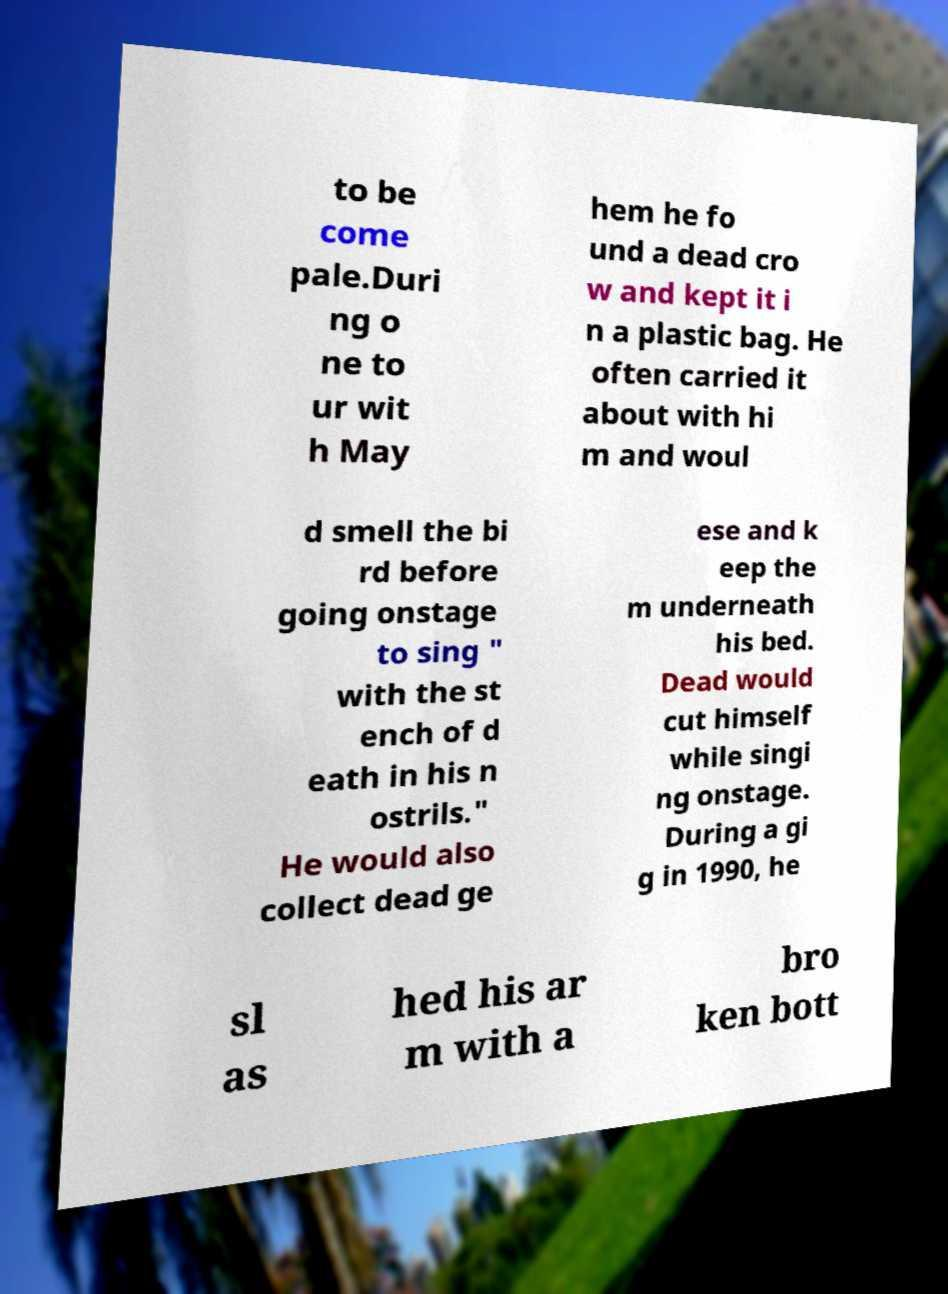What messages or text are displayed in this image? I need them in a readable, typed format. to be come pale.Duri ng o ne to ur wit h May hem he fo und a dead cro w and kept it i n a plastic bag. He often carried it about with hi m and woul d smell the bi rd before going onstage to sing " with the st ench of d eath in his n ostrils." He would also collect dead ge ese and k eep the m underneath his bed. Dead would cut himself while singi ng onstage. During a gi g in 1990, he sl as hed his ar m with a bro ken bott 